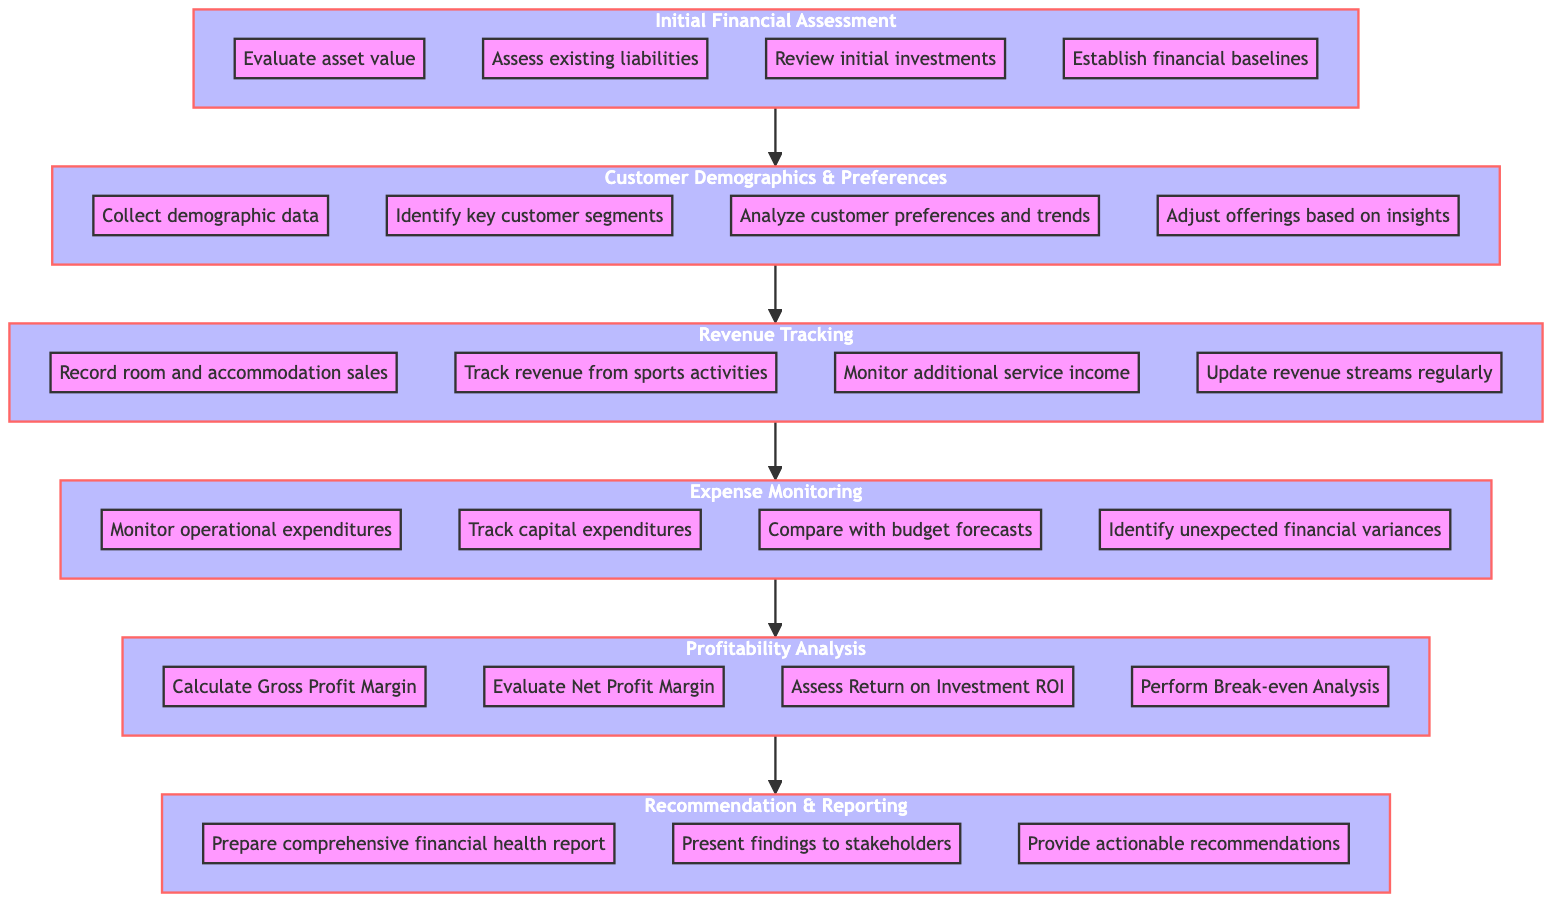What is the first step in the financial health check of sport-themed resort facilities? The first step is labeled as "Initial Financial Assessment." This can be identified as it is the bottommost node in the flow chart, indicating it is the initial phase in the process.
Answer: Initial Financial Assessment How many substeps are there in the "Profitability Analysis" step? The "Profitability Analysis" step contains four substeps as identified in the flow chart. Listing the substeps confirms that there are four distinct actions within this step.
Answer: Four What is the relationship between "Revenue Tracking" and "Expense Monitoring"? "Revenue Tracking" is a direct predecessor to "Expense Monitoring" in the flow, indicating that money inflow needs to be tracked before monitoring expenses. This relationship is shown by the directed arrow that connects the two nodes.
Answer: Revenue Tracking is before Expense Monitoring Which step directly follows "Customer Demographics & Preferences"? The step that directly follows "Customer Demographics & Preferences" is "Revenue Tracking" as indicated by the directed flow in the chart that moves upward from one step to the next.
Answer: Revenue Tracking How many main steps are involved in the financial health check process? The financial health check process consists of six main steps. This is derived from counting the total number of labeled steps in the flowchart from the bottom to the top.
Answer: Six What is the last action to be performed in the financial health check program? The last action is "Provide actionable recommendations." This is the final substep of the "Recommendation & Reporting" step, which is the topmost step in the flowchart.
Answer: Provide actionable recommendations Which step precedes "Expense Monitoring"? "Revenue Tracking" is the step that precedes "Expense Monitoring," as indicated by the directed connection between them in the flow chart.
Answer: Revenue Tracking What type of data is collected in the second step? The second step involves collecting demographic data. This is explicitly mentioned in the description of the "Customer Demographics & Preferences" step.
Answer: Demographic data 